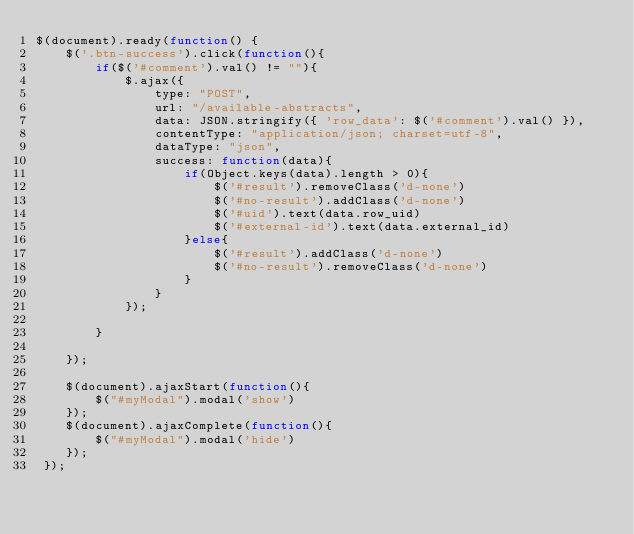<code> <loc_0><loc_0><loc_500><loc_500><_JavaScript_>$(document).ready(function() {
    $('.btn-success').click(function(){
        if($('#comment').val() != ""){
            $.ajax({
                type: "POST",
                url: "/available-abstracts",
                data: JSON.stringify({ 'row_data': $('#comment').val() }),
                contentType: "application/json; charset=utf-8",
                dataType: "json",
                success: function(data){
                    if(Object.keys(data).length > 0){
                        $('#result').removeClass('d-none')
                        $('#no-result').addClass('d-none')
                        $('#uid').text(data.row_uid)
                        $('#external-id').text(data.external_id)
                    }else{
                        $('#result').addClass('d-none')
                        $('#no-result').removeClass('d-none')
                    }
                }
            });
            
        }
        
    });

    $(document).ajaxStart(function(){
        $("#myModal").modal('show')
    });
    $(document).ajaxComplete(function(){
        $("#myModal").modal('hide')
    });
 });</code> 